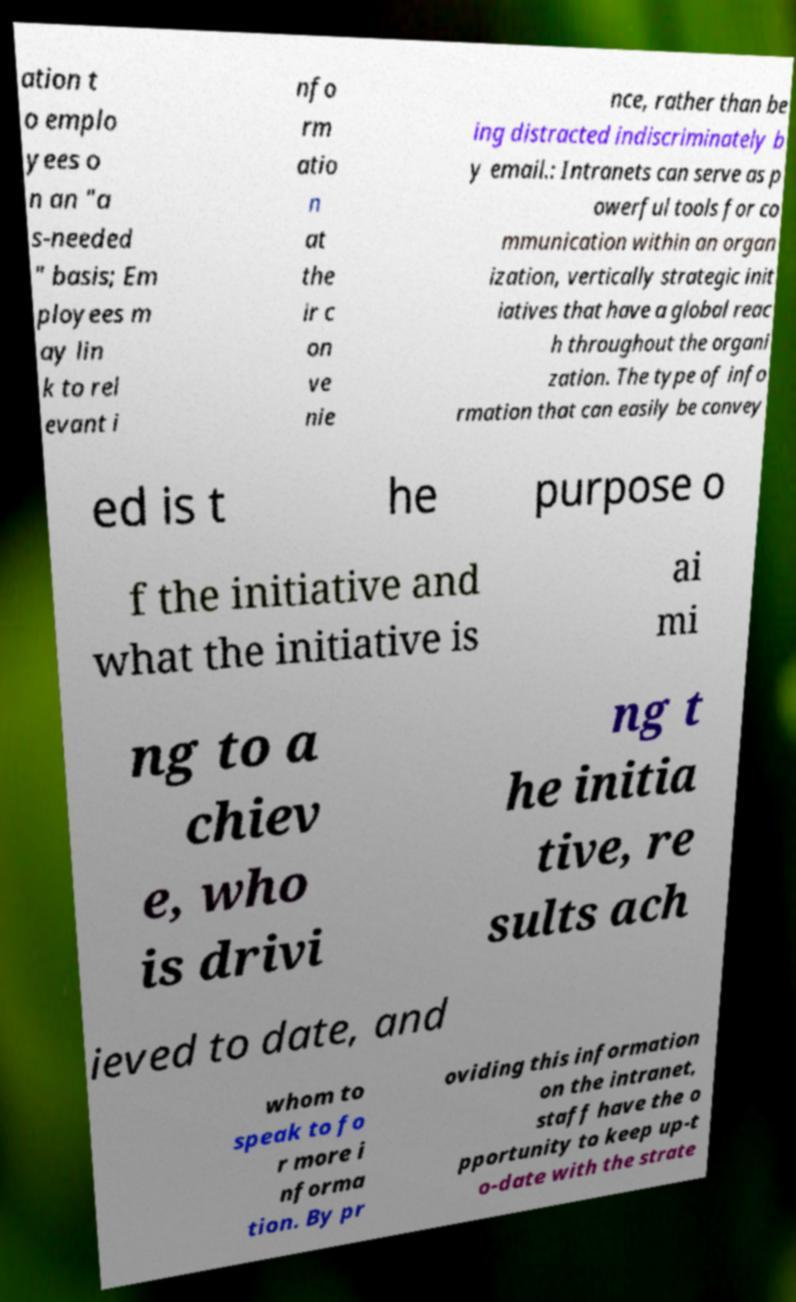Please read and relay the text visible in this image. What does it say? ation t o emplo yees o n an "a s-needed " basis; Em ployees m ay lin k to rel evant i nfo rm atio n at the ir c on ve nie nce, rather than be ing distracted indiscriminately b y email.: Intranets can serve as p owerful tools for co mmunication within an organ ization, vertically strategic init iatives that have a global reac h throughout the organi zation. The type of info rmation that can easily be convey ed is t he purpose o f the initiative and what the initiative is ai mi ng to a chiev e, who is drivi ng t he initia tive, re sults ach ieved to date, and whom to speak to fo r more i nforma tion. By pr oviding this information on the intranet, staff have the o pportunity to keep up-t o-date with the strate 